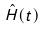Convert formula to latex. <formula><loc_0><loc_0><loc_500><loc_500>\hat { H } ( t )</formula> 